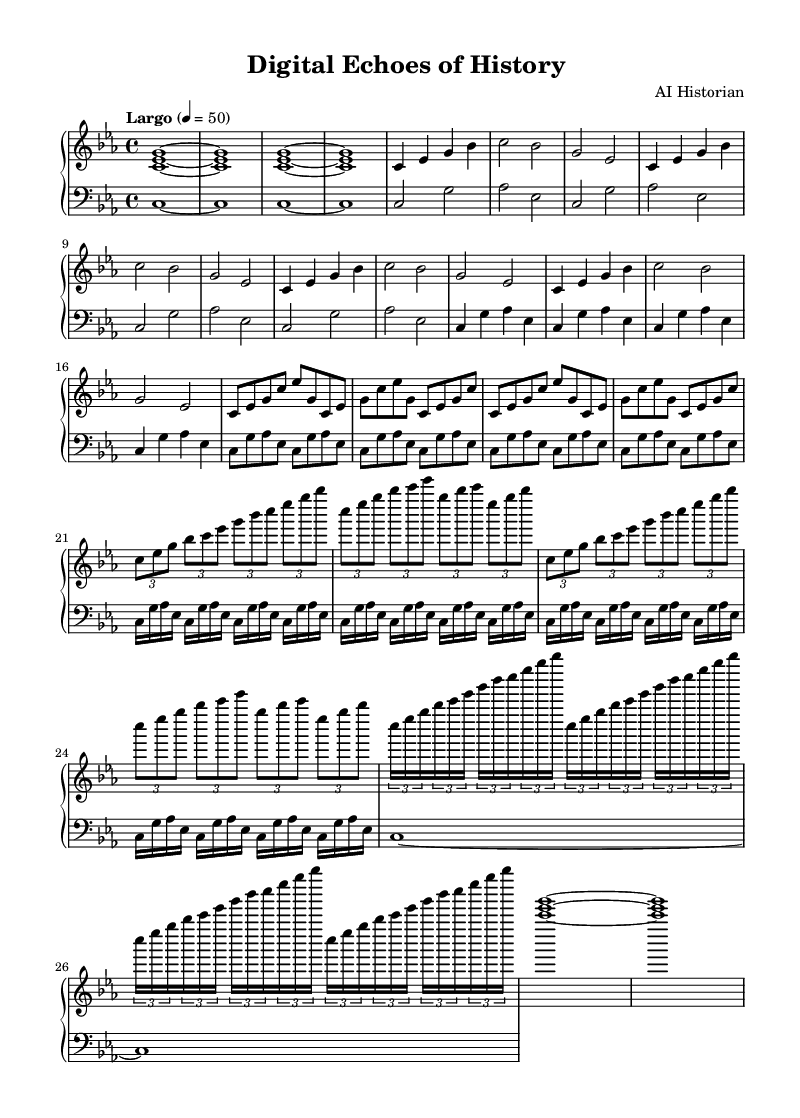What is the key signature of this music? The key signature indicates the piece is in C minor, which has three flats (B flat, E flat, and A flat). This can be determined from the key signature indicated at the beginning of the sheet music.
Answer: C minor What is the time signature of the piece? The time signature is provided after the clef and indicates the rhythm of the piece. In this case, it is 4/4, meaning there are four beats in each measure and the quarter note gets one beat.
Answer: 4/4 What is the tempo marking for this composition? The tempo is written above the staff as "Largo," which is a term used to describe a slow tempo. Additionally, the number given (4 = 50) indicates that there are 50 beats per minute.
Answer: Largo How many sections are there in the right-hand part? Observing the structure in the right-hand part, there are five distinct sections: Introduction, Ancient, Medieval, Renaissance, and Modern, plus a Coda at the end. This can be determined by the labels and the repetition patterns throughout the part.
Answer: Five What is the relationship between the ancient and medieval sections in terms of rhythm? The ancient section consists of longer notes represented by quarter notes, whereas the medieval section introduces eighth notes and increases the rhythmic complexity. The analysis shows a shift from simpler to more intricate rhythmic patterns, reflecting the evolution of music over time.
Answer: Shift to complexity How does the harmony progress from the Renaissance to the Modern section? The Renaissance section utilizes more complex harmonies with tuplets, while the Modern section simplifies these rhythms and focuses on shorter note values, indicating a shift towards minimalism. This can be deduced by comparing the rhythmic patterns and the density of notes in each section.
Answer: Simplification of rhythms What instruments are indicated in the score? The score features a PianoStaff which is used for piano compositions, as indicated by the clef symbols and the fact that both right-hand and left-hand parts are designed for a piano player. The presence of two staves suggests a standard piano setup.
Answer: Piano 